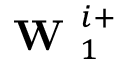<formula> <loc_0><loc_0><loc_500><loc_500>W _ { 1 } ^ { i + }</formula> 